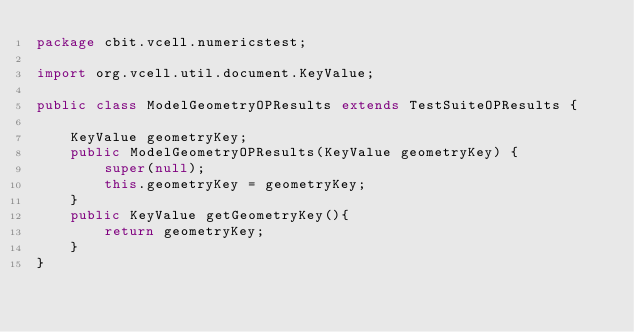Convert code to text. <code><loc_0><loc_0><loc_500><loc_500><_Java_>package cbit.vcell.numericstest;

import org.vcell.util.document.KeyValue;

public class ModelGeometryOPResults extends TestSuiteOPResults {

	KeyValue geometryKey;
	public ModelGeometryOPResults(KeyValue geometryKey) {
		super(null);
		this.geometryKey = geometryKey;
	}
	public KeyValue getGeometryKey(){
		return geometryKey;
	}
}
</code> 